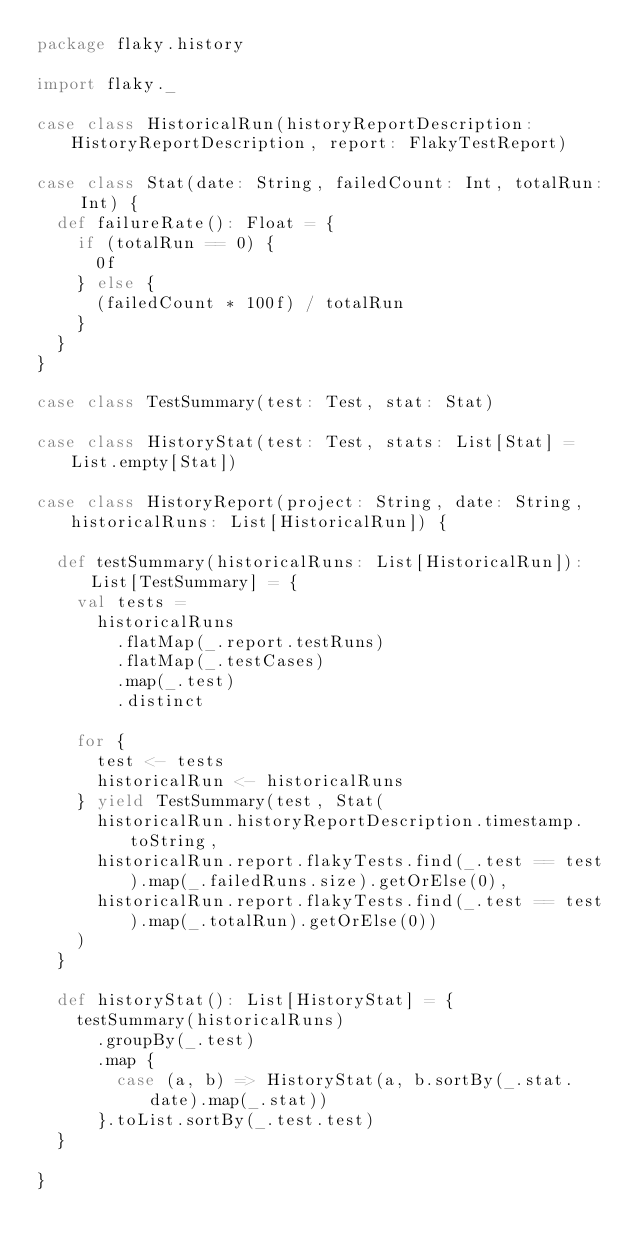<code> <loc_0><loc_0><loc_500><loc_500><_Scala_>package flaky.history

import flaky._

case class HistoricalRun(historyReportDescription: HistoryReportDescription, report: FlakyTestReport)

case class Stat(date: String, failedCount: Int, totalRun: Int) {
  def failureRate(): Float = {
    if (totalRun == 0) {
      0f
    } else {
      (failedCount * 100f) / totalRun
    }
  }
}

case class TestSummary(test: Test, stat: Stat)

case class HistoryStat(test: Test, stats: List[Stat] = List.empty[Stat])

case class HistoryReport(project: String, date: String, historicalRuns: List[HistoricalRun]) {

  def testSummary(historicalRuns: List[HistoricalRun]): List[TestSummary] = {
    val tests =
      historicalRuns
        .flatMap(_.report.testRuns)
        .flatMap(_.testCases)
        .map(_.test)
        .distinct

    for {
      test <- tests
      historicalRun <- historicalRuns
    } yield TestSummary(test, Stat(
      historicalRun.historyReportDescription.timestamp.toString,
      historicalRun.report.flakyTests.find(_.test == test).map(_.failedRuns.size).getOrElse(0),
      historicalRun.report.flakyTests.find(_.test == test).map(_.totalRun).getOrElse(0))
    )
  }

  def historyStat(): List[HistoryStat] = {
    testSummary(historicalRuns)
      .groupBy(_.test)
      .map {
        case (a, b) => HistoryStat(a, b.sortBy(_.stat.date).map(_.stat))
      }.toList.sortBy(_.test.test)
  }

}
</code> 